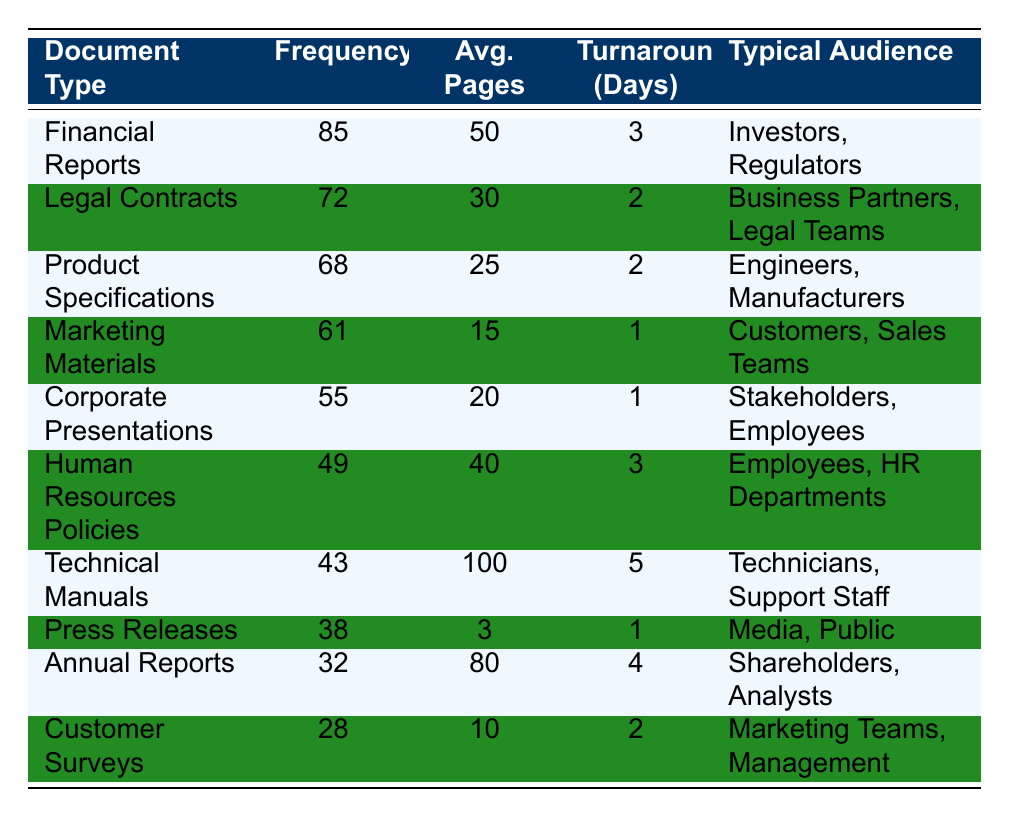What is the most frequently translated document type? The table shows that "Financial Reports" has the highest frequency with a count of 85.
Answer: Financial Reports What is the average number of pages for Legal Contracts? According to the table, "Legal Contracts" has an average of 30 pages.
Answer: 30 Which document type has the longest turnaround time? The table lists "Technical Manuals" with a turnaround time of 5 days, which is the longest compared to other document types.
Answer: Technical Manuals What is the frequency difference between Product Specifications and Human Resources Policies? The frequency of "Product Specifications" is 68 and for "Human Resources Policies" it is 49. The difference is 68 - 49 = 19.
Answer: 19 What is the average turnaround time for Corporate Presentations and Marketing Materials? "Corporate Presentations" has a turnaround time of 1 day and "Marketing Materials" also has a turnaround time of 1 day. The average is (1 + 1) / 2 = 1 day.
Answer: 1 Are there more frequent translations of Annual Reports than Customer Surveys? The frequency for "Annual Reports" is 32 while for "Customer Surveys" it is 28. Therefore, yes, there are more frequent translations of Annual Reports.
Answer: Yes What is the typical audience for Technical Manuals? The typical audience for "Technical Manuals," as listed in the table, is "Technicians, Support Staff."
Answer: Technicians, Support Staff If the total frequency of all document types is considered, what percentage of that frequency do Financial Reports represent? The total frequency is 85 + 72 + 68 + 61 + 55 + 49 + 43 + 38 + 32 + 28 =  498. The percentage for "Financial Reports" is (85 / 498) * 100, which is approximately 17.06%.
Answer: 17.06% Which type of document has the lowest average number of pages and what is that number? The table shows "Press Releases" with the lowest average at 3 pages.
Answer: 3 Which document types are primarily targeted towards employees? "Corporate Presentations," "Human Resources Policies," and "Press Releases" target employees as per the details provided in the table.
Answer: Corporate Presentations, Human Resources Policies, Press Releases 